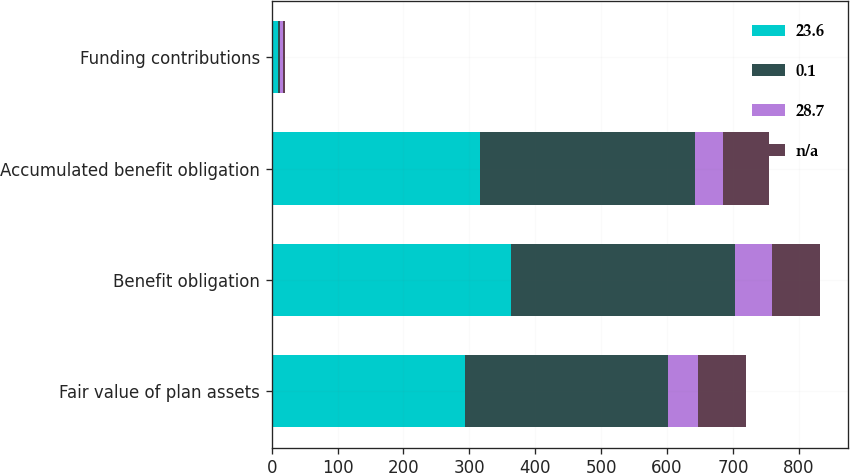Convert chart. <chart><loc_0><loc_0><loc_500><loc_500><stacked_bar_chart><ecel><fcel>Fair value of plan assets<fcel>Benefit obligation<fcel>Accumulated benefit obligation<fcel>Funding contributions<nl><fcel>23.6<fcel>293.6<fcel>363<fcel>315.8<fcel>9.3<nl><fcel>0.1<fcel>308.4<fcel>340.2<fcel>326.3<fcel>3.3<nl><fcel>28.7<fcel>45<fcel>56.7<fcel>43.3<fcel>4.9<nl><fcel>nan<fcel>72.9<fcel>72.5<fcel>69.7<fcel>2.6<nl></chart> 